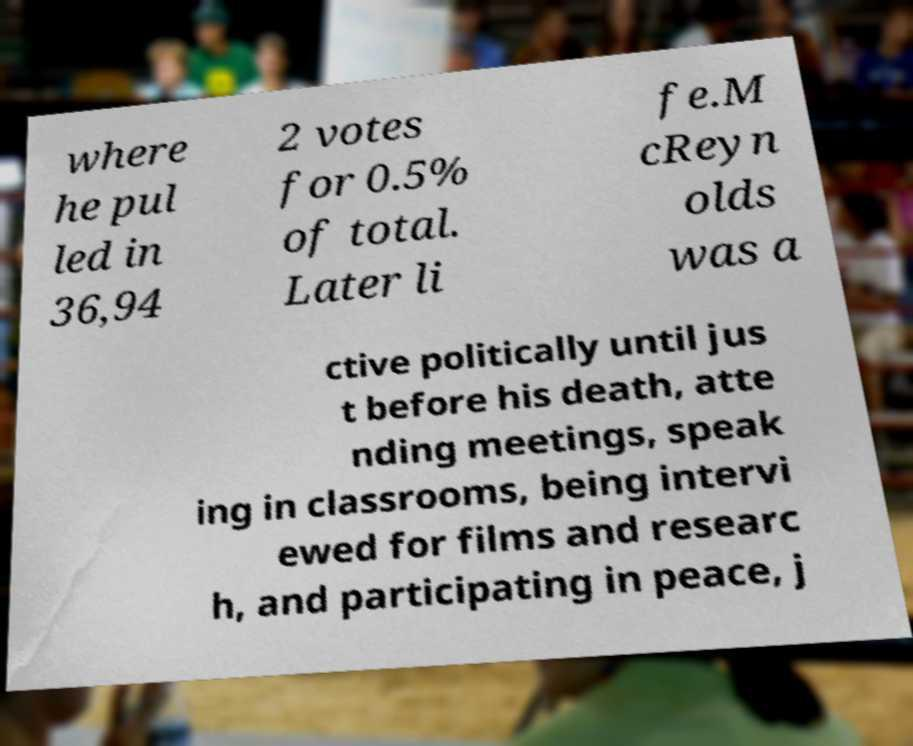Could you extract and type out the text from this image? where he pul led in 36,94 2 votes for 0.5% of total. Later li fe.M cReyn olds was a ctive politically until jus t before his death, atte nding meetings, speak ing in classrooms, being intervi ewed for films and researc h, and participating in peace, j 